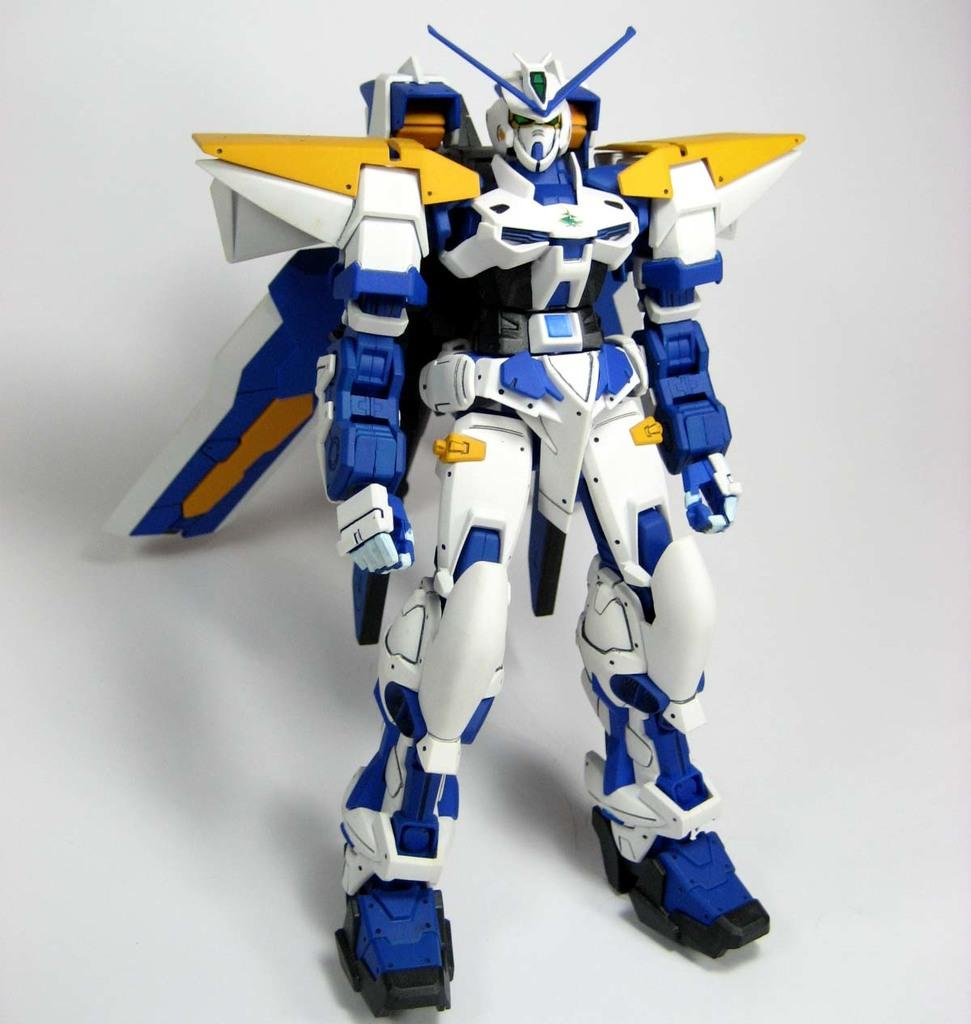What is the color of the toy in the image? The toy in the image is white and blue. What is the toy placed on in the image? The toy is placed on a white color object. What type of government is depicted in the image? There is no depiction of a government in the image; it features a white and blue color toy placed on a white color object. 